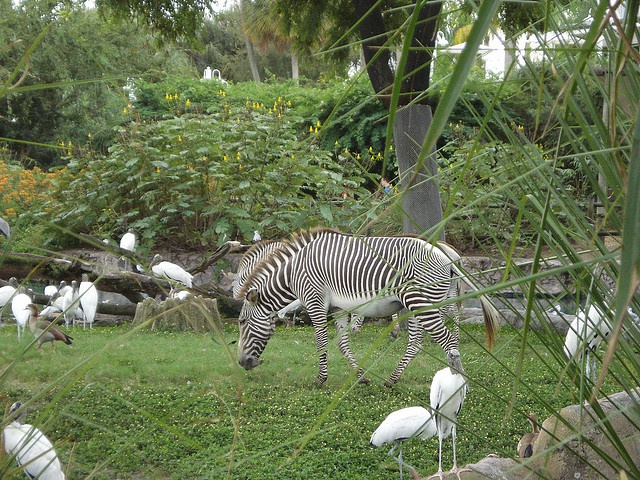Describe the objects in this image and their specific colors. I can see zebra in darkgreen, gray, white, darkgray, and black tones, bird in darkgreen, white, darkgray, and gray tones, bird in darkgreen, lightgray, darkgray, and gray tones, bird in darkgreen, white, darkgray, and gray tones, and bird in darkgreen, lightgray, gray, and darkgray tones in this image. 